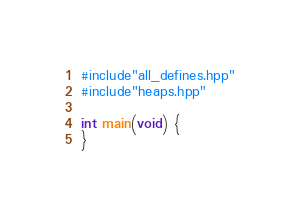<code> <loc_0><loc_0><loc_500><loc_500><_C++_>#include"all_defines.hpp"
#include"heaps.hpp"

int main(void) {
}

</code> 